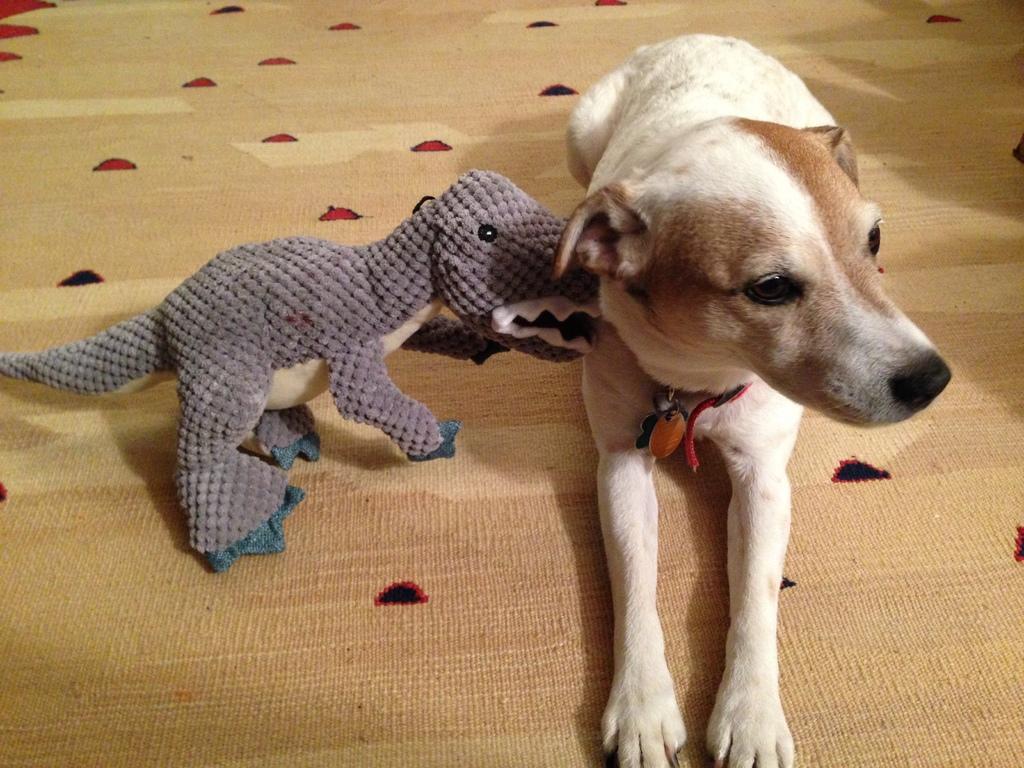In one or two sentences, can you explain what this image depicts? In this image in the center there is a dog sitting on the floor and there is a toy on the floor. 